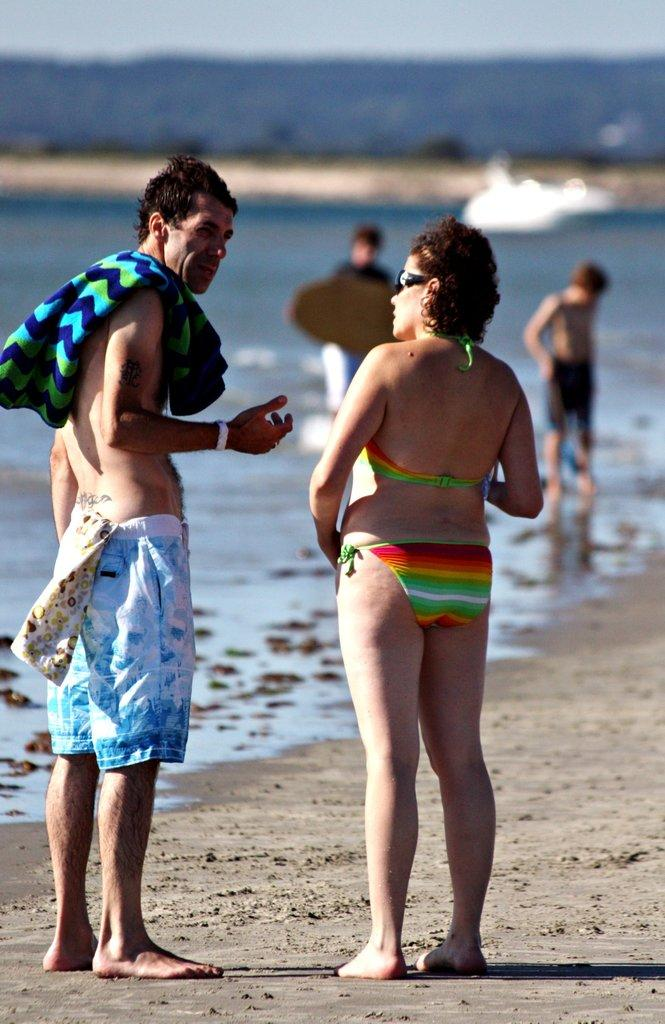How many people are present in the image? There are two people, a man and a woman, present in the image. What is the man wearing in the image? The man is wearing shorts in the image. What is the man carrying in the image? The man is carrying a towel in the image. What can be seen in the background of the image? There is water, people, and the sky visible in the background of the image. What type of spade is being used by the protesters in the image? There are no protesters or spades present in the image. How many tomatoes are visible on the table in the image? There is no table or tomatoes present in the image. 